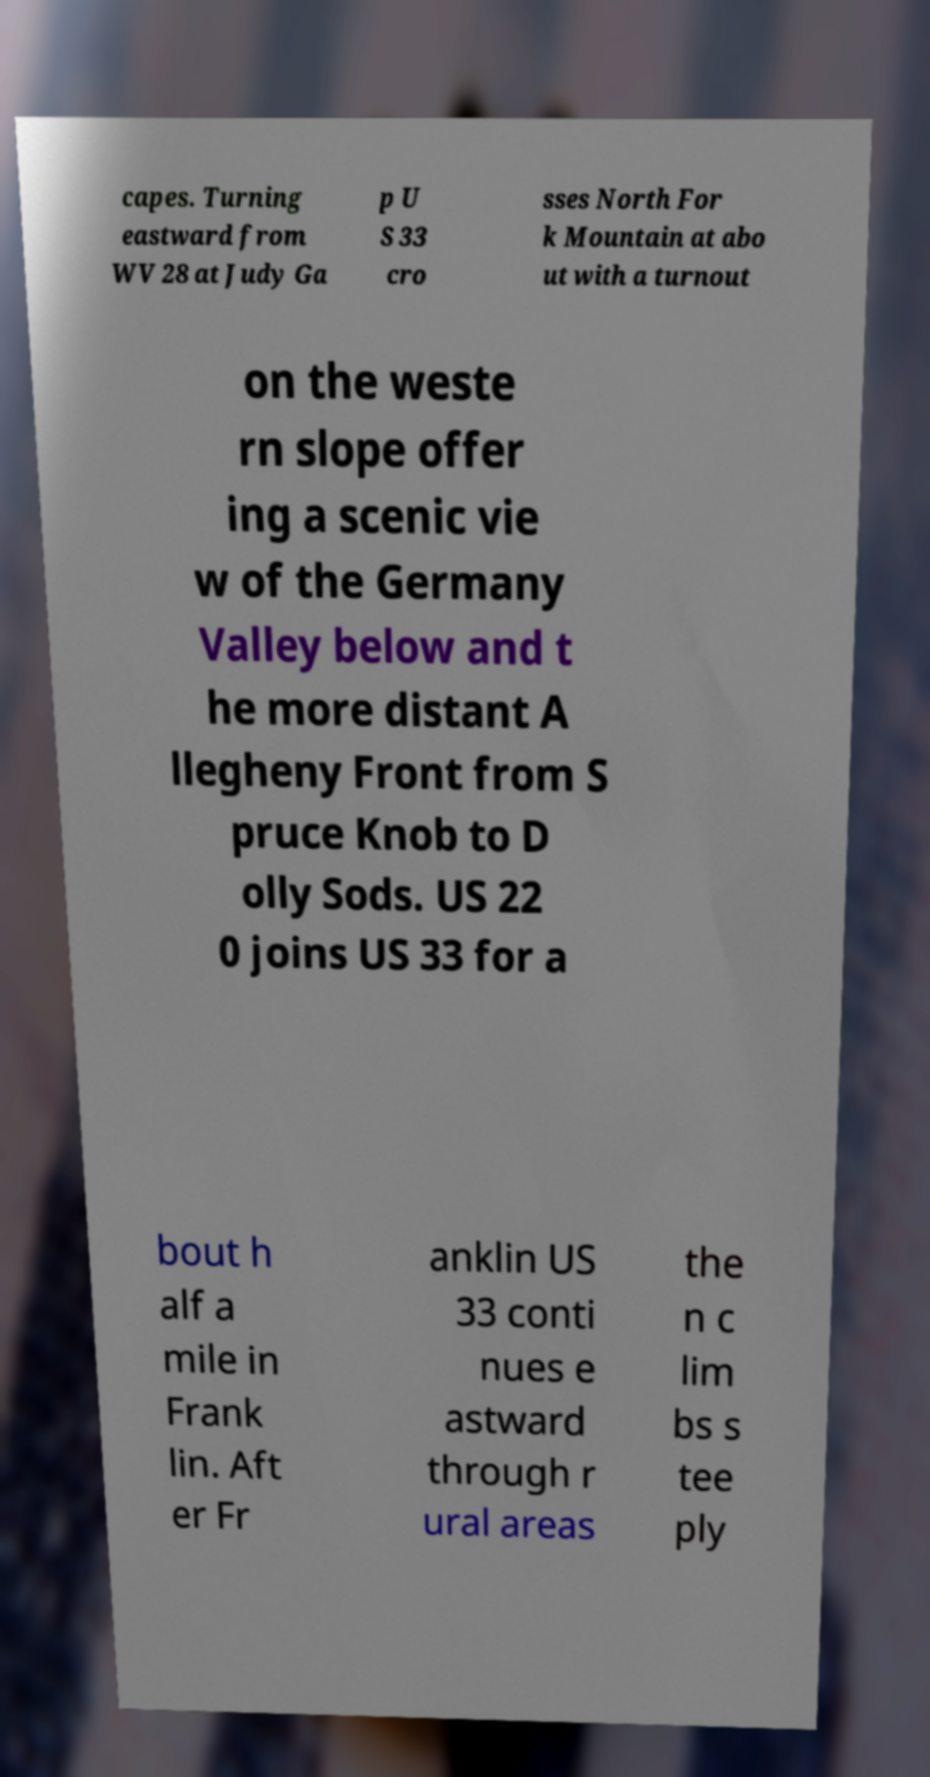Could you extract and type out the text from this image? capes. Turning eastward from WV 28 at Judy Ga p U S 33 cro sses North For k Mountain at abo ut with a turnout on the weste rn slope offer ing a scenic vie w of the Germany Valley below and t he more distant A llegheny Front from S pruce Knob to D olly Sods. US 22 0 joins US 33 for a bout h alf a mile in Frank lin. Aft er Fr anklin US 33 conti nues e astward through r ural areas the n c lim bs s tee ply 